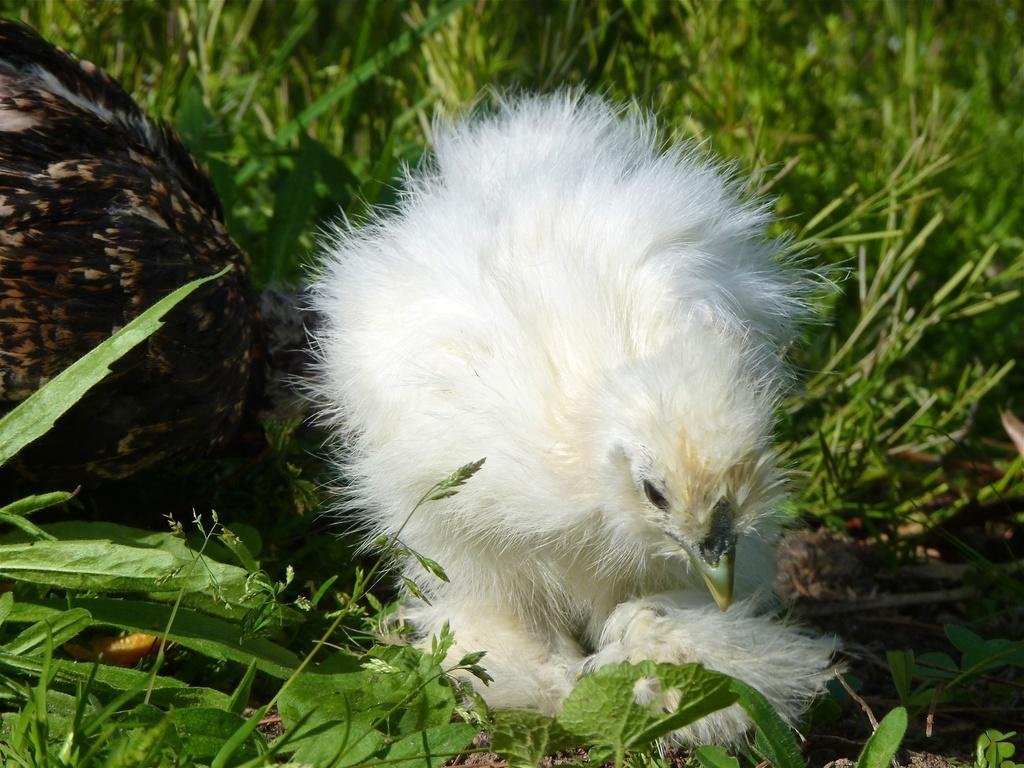What type of animals are in the image? There are chickens in the image. What colors are the chickens? The chickens are black and white in color. Where are the chickens located? The chickens are on the grass. What type of trains can be seen in the image? There are no trains present in the image; it features chickens on the grass. What unit of measurement is used to describe the size of the chickens in the image? The provided facts do not mention any specific unit of measurement for the size of the chickens. 